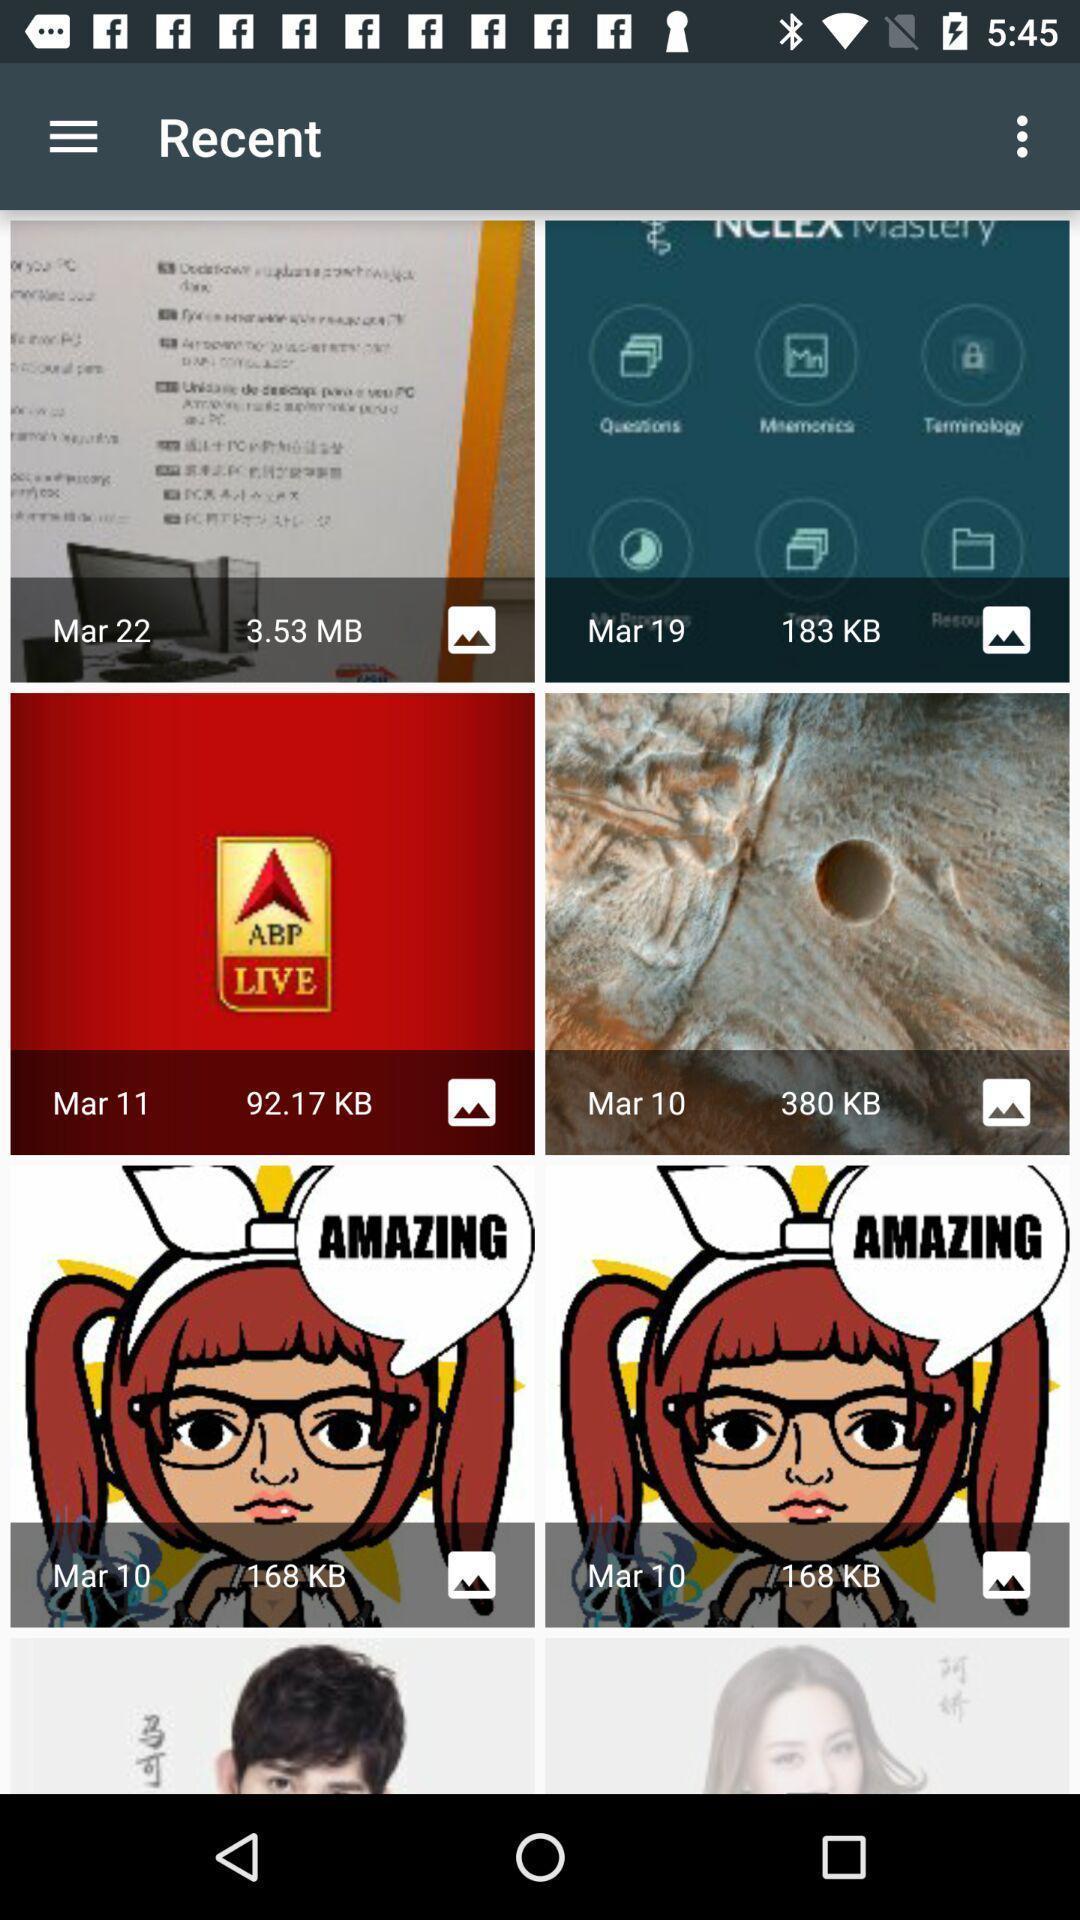Tell me about the visual elements in this screen capture. Screen displaying about recent images. 